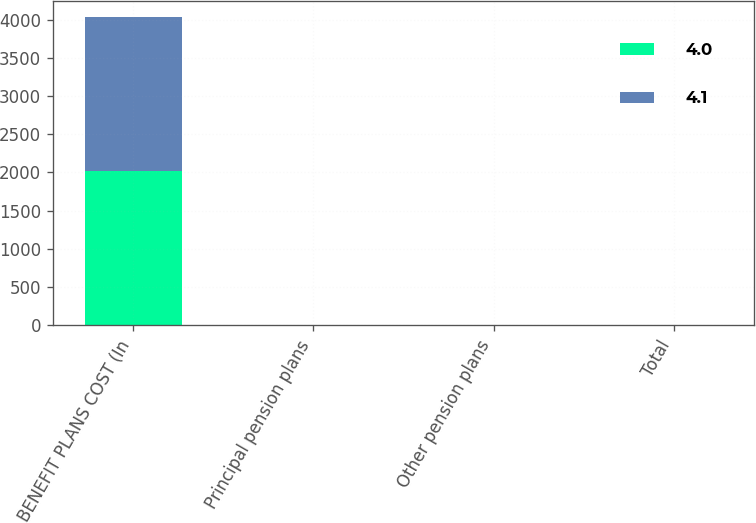Convert chart. <chart><loc_0><loc_0><loc_500><loc_500><stacked_bar_chart><ecel><fcel>BENEFIT PLANS COST (In<fcel>Principal pension plans<fcel>Other pension plans<fcel>Total<nl><fcel>4<fcel>2018<fcel>4.3<fcel>0.1<fcel>4.1<nl><fcel>4.1<fcel>2017<fcel>3.7<fcel>0.3<fcel>4<nl></chart> 